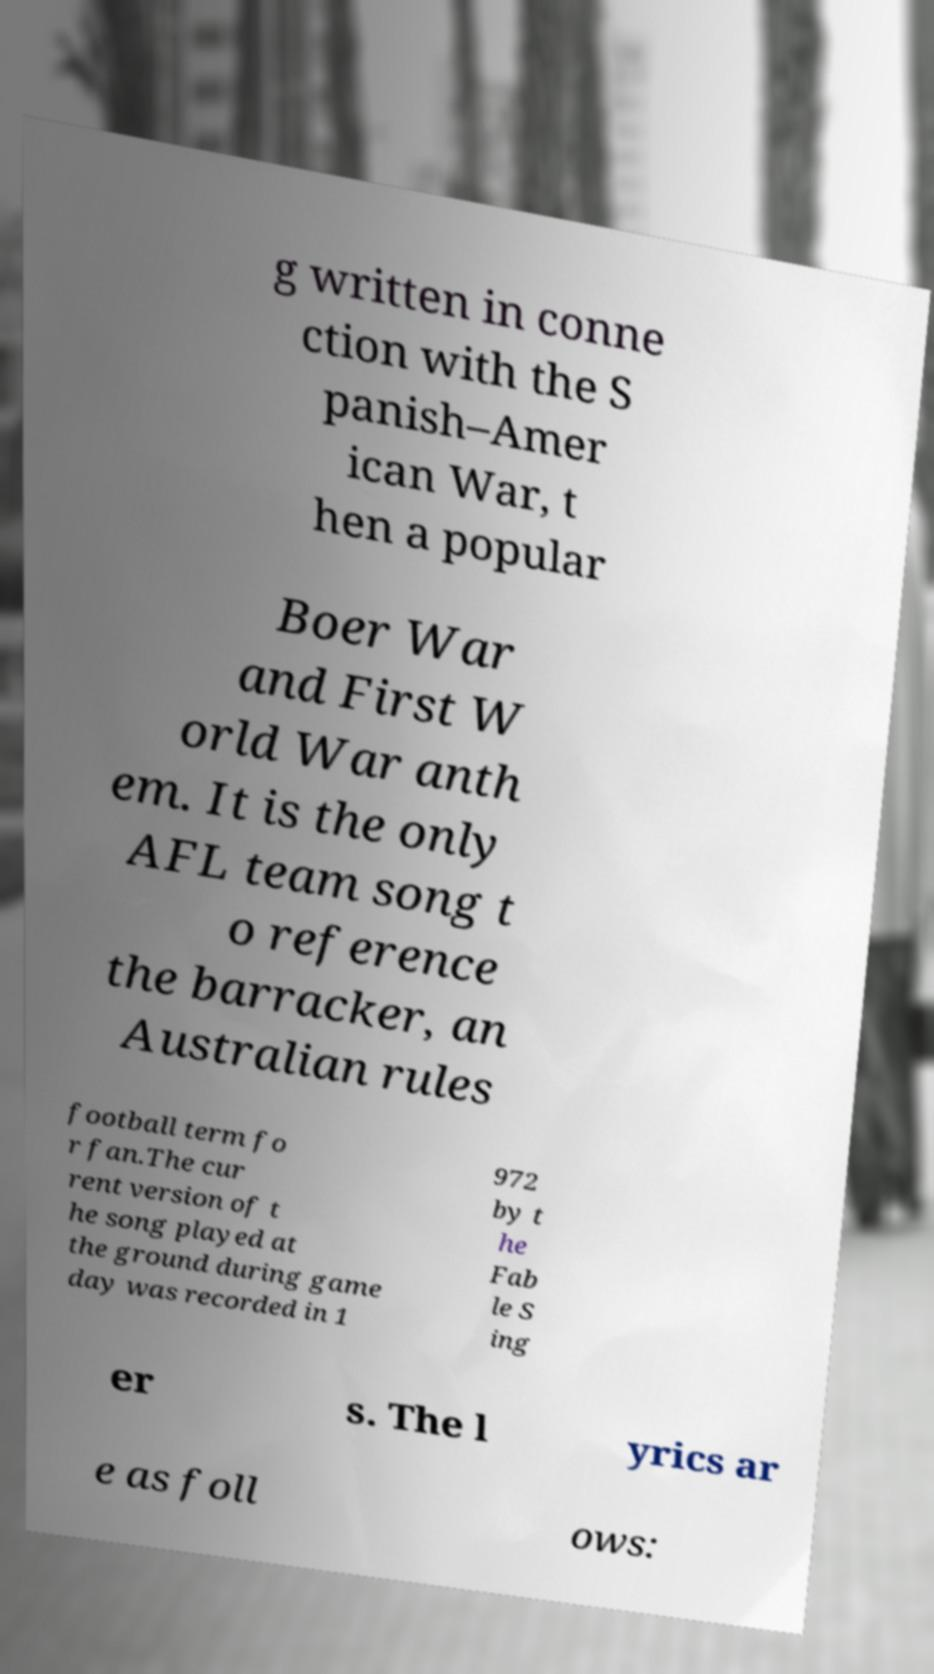Please read and relay the text visible in this image. What does it say? g written in conne ction with the S panish–Amer ican War, t hen a popular Boer War and First W orld War anth em. It is the only AFL team song t o reference the barracker, an Australian rules football term fo r fan.The cur rent version of t he song played at the ground during game day was recorded in 1 972 by t he Fab le S ing er s. The l yrics ar e as foll ows: 